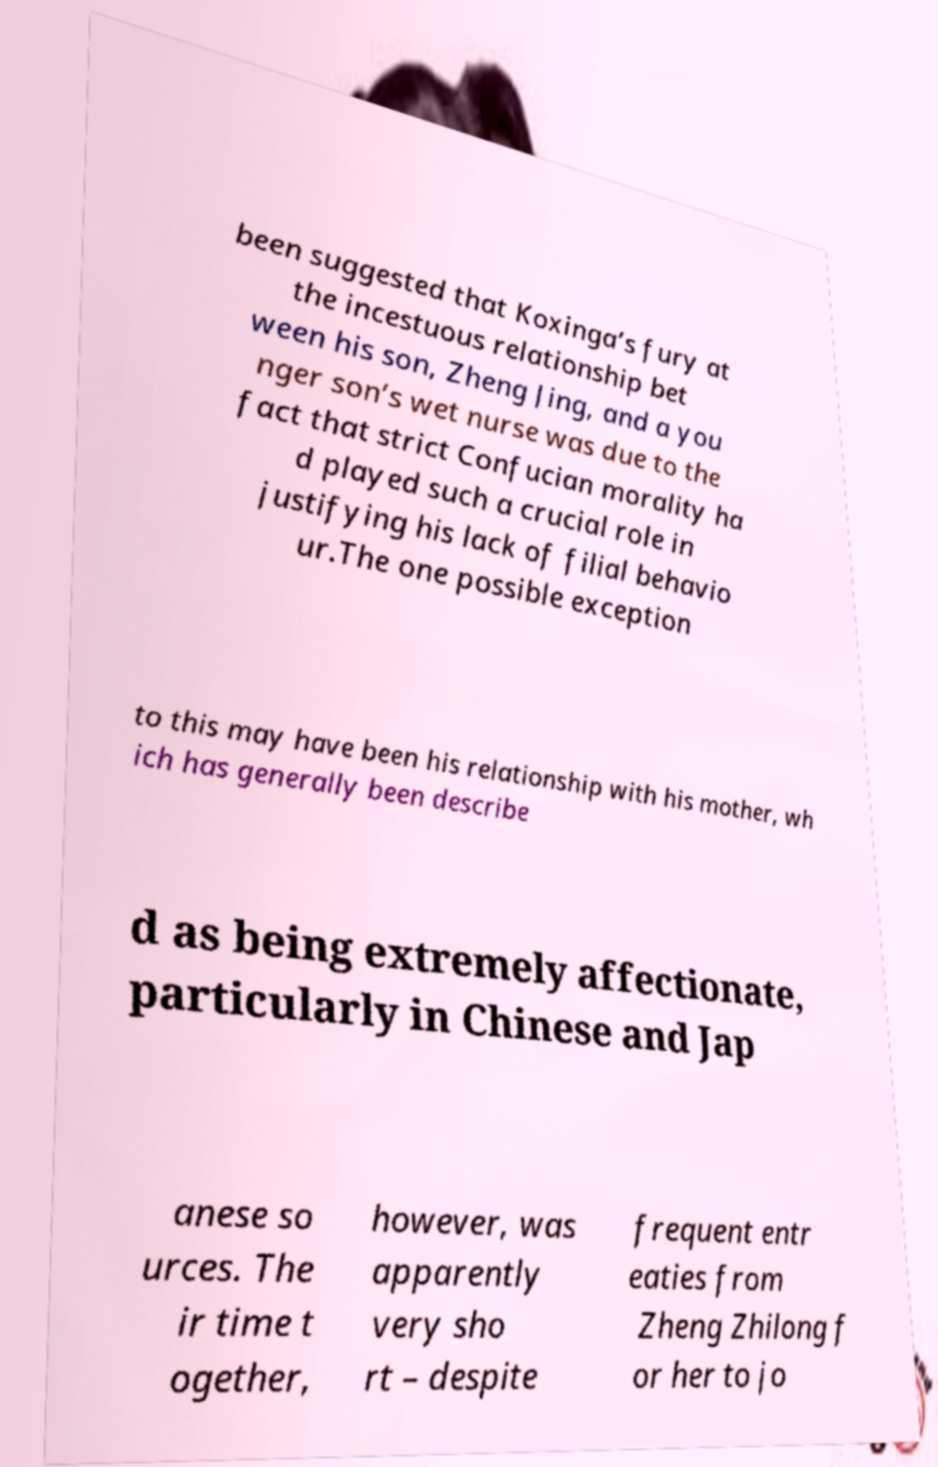I need the written content from this picture converted into text. Can you do that? been suggested that Koxinga’s fury at the incestuous relationship bet ween his son, Zheng Jing, and a you nger son’s wet nurse was due to the fact that strict Confucian morality ha d played such a crucial role in justifying his lack of filial behavio ur.The one possible exception to this may have been his relationship with his mother, wh ich has generally been describe d as being extremely affectionate, particularly in Chinese and Jap anese so urces. The ir time t ogether, however, was apparently very sho rt – despite frequent entr eaties from Zheng Zhilong f or her to jo 